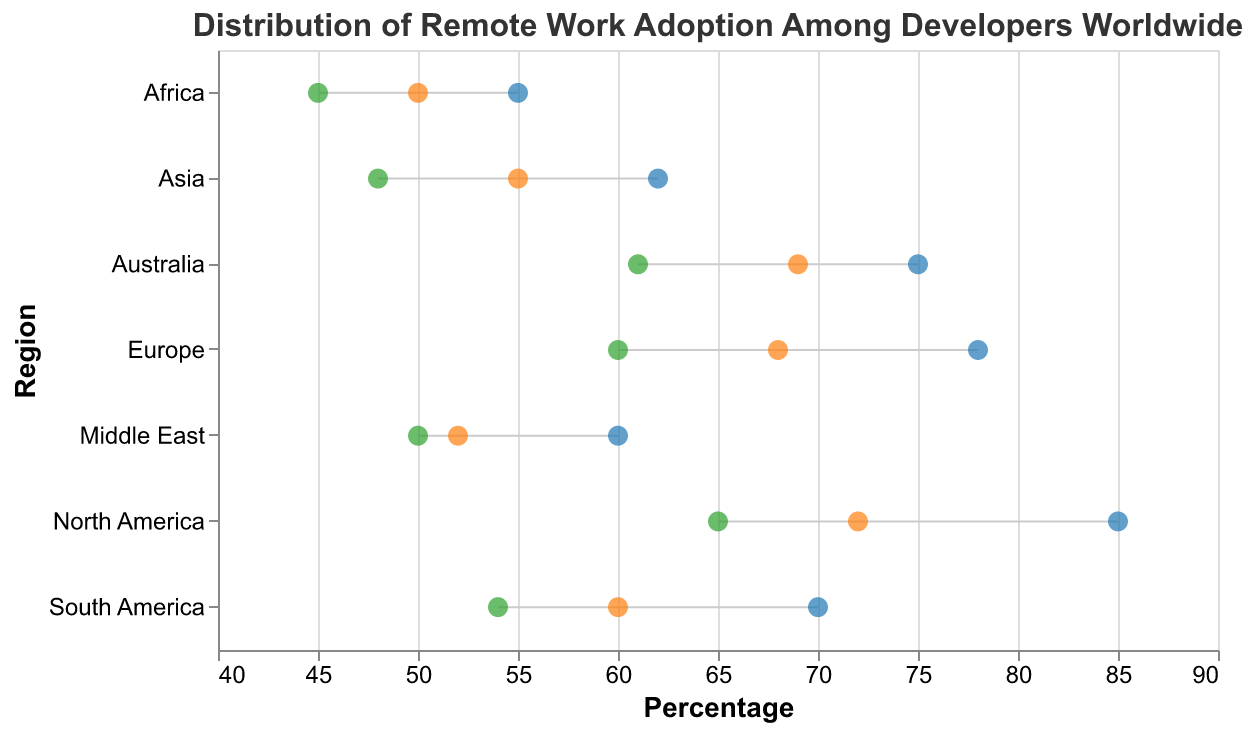What is the title of the figure? The title is located at the top of the figure. Based on the provided data and code, it is directly mentioned in the "title" section.
Answer: Distribution of Remote Work Adoption Among Developers Worldwide Which region has the highest percentage of developers adopting remote work? To find out which region has the highest percentage of adopting remote work, look for the region with the highest value in the data points represented in blue.
Answer: North America What is the difference between the percentage of developers who prefer remote work and those adopting remote work in Europe? Locate the values for Europe: Percentage_Preferring_Remote_Work is 68 and Percentage_Adopting_Remote_Work is 78. The difference is calculated as 78 - 68.
Answer: 10 Which region has the lowest percentage of developers adopting hybrid work? Look for the green data points across the regions and identify the lowest value. The data indicates that Africa has the lowest percentage of developers adopting hybrid work at 45%.
Answer: Africa What is the average percentage of developers preferring remote work in all regions? Sum the percentages of developers preferring remote work across all regions (72, 68, 55, 60, 69, 50, 52) and divide by the number of regions (7). The calculation is (72 + 68 + 55 + 60 + 69 + 50 + 52) / 7.
Answer: 60.86 Compare the percentage of developers adopting remote work in South America and Asia. Which is higher, and by how much? South America's percentage of adopting remote work is 70, and Asia's is 62. The difference is calculated as 70 - 62.
Answer: South America by 8 How does the percentage of developers adopting hybrid work in Australia compare to those in North America? North America’s percentage of adopting hybrid work is 65, and Australia’s is 61. The difference is calculated as 65 - 61.
Answer: North America by 4 Identify the range of values for percentages of adopting remote work across all regions. The range is determined by the maximum and minimum values of the Percentage_Adopting_Remote_Work column. The maximum is 85 (North America) and the minimum is 55 (Africa). The range is calculated as 85 - 55.
Answer: 30 Which region has the closest percentages of preferring remote work and adopting hybrid work? Compare the values for the percentage of preferring remote work and adopting hybrid work across all regions to find the closest pair. Middle East has 52% preferring remote work and 50% adopting hybrid work, which is a difference of 2.
Answer: Middle East 